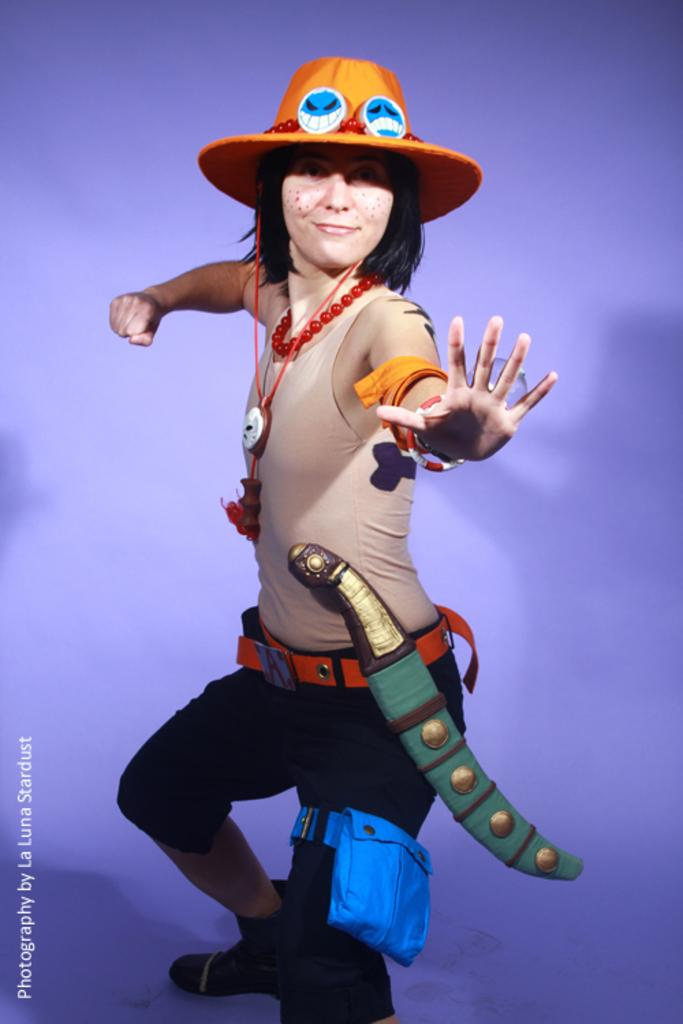Who is present in the image? There is a woman in the image. What is the woman doing in the image? The woman is standing on a surface. What is the woman wearing in the image? The woman is wearing a costume. Can you tell me how many donkeys are present in the image? There are no donkeys present in the image; it features a woman wearing a costume. What type of birth can be seen taking place in the image? There is no birth depicted in the image; it features a woman standing on a surface while wearing a costume. 